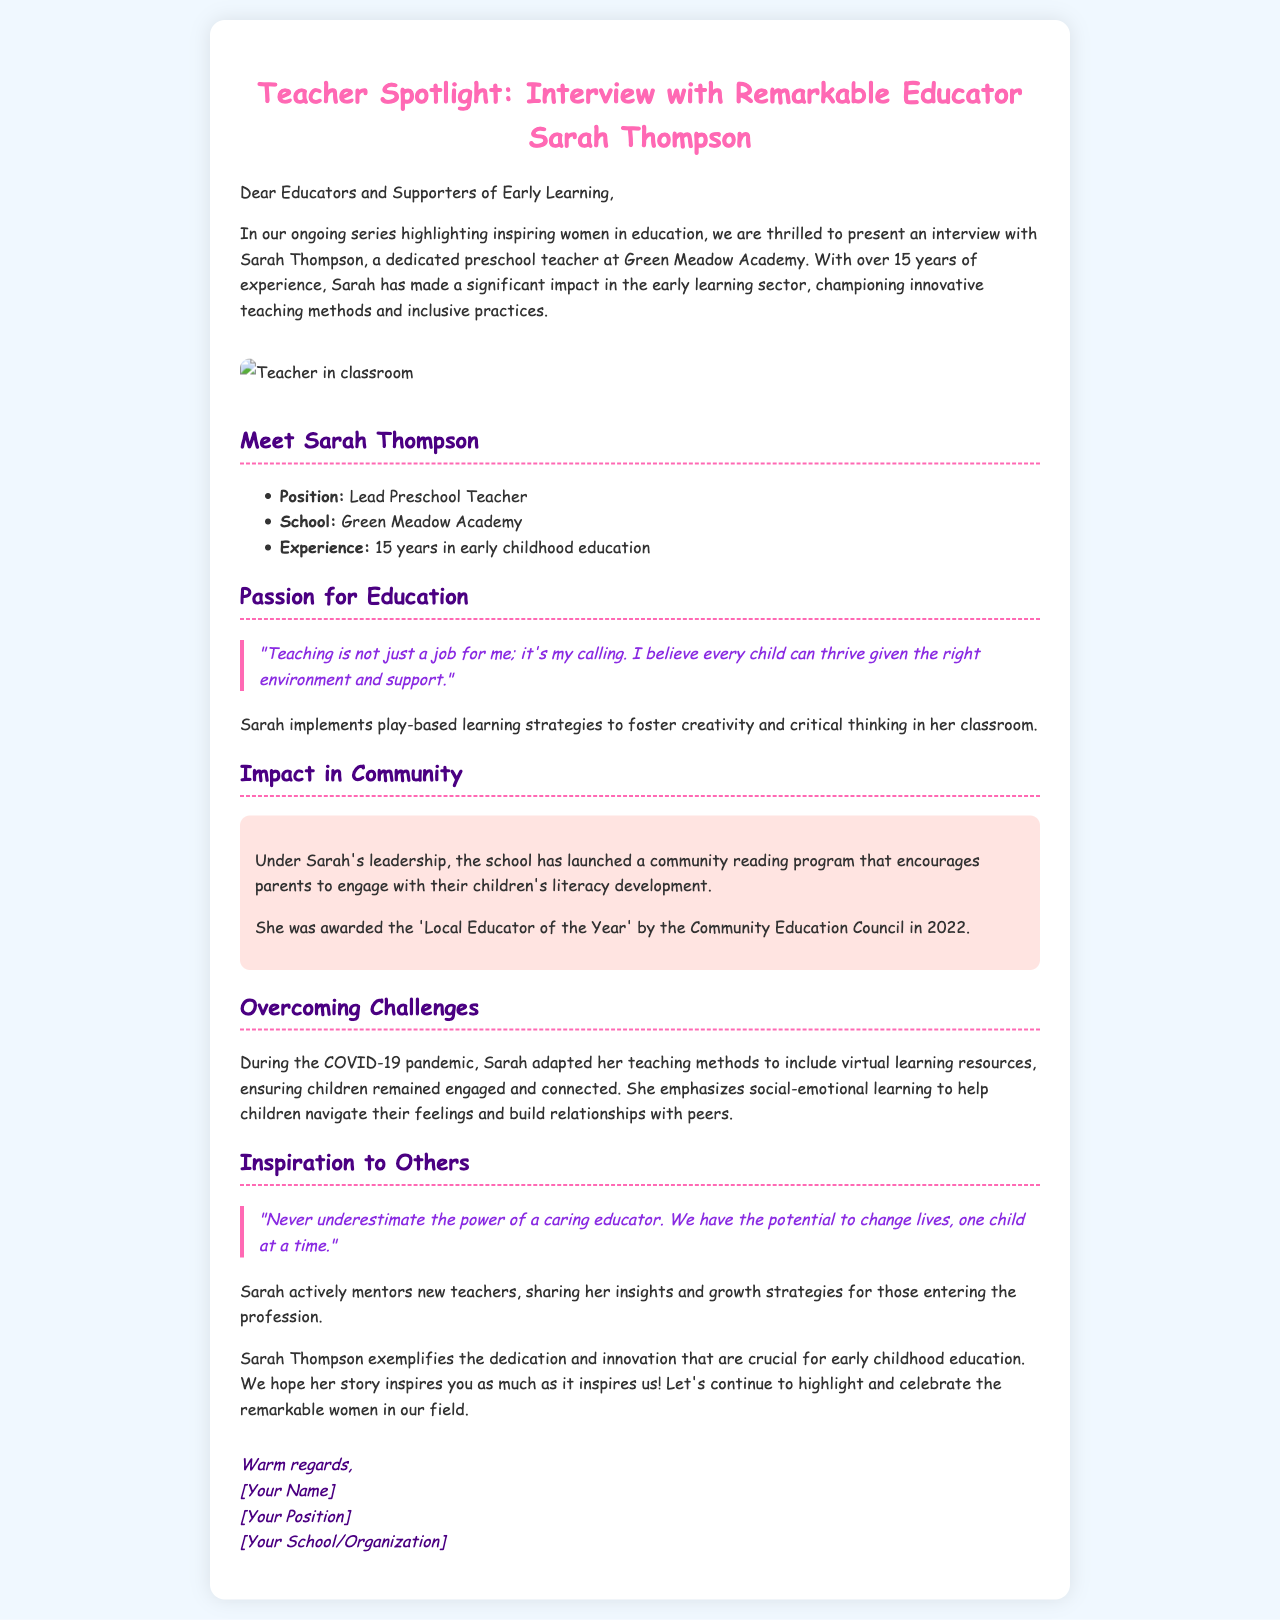What is the name of the featured educator? The document highlights an interview with Sarah Thompson.
Answer: Sarah Thompson What position does Sarah Thompson hold? Sarah is identified as the Lead Preschool Teacher at Green Meadow Academy.
Answer: Lead Preschool Teacher How many years of experience does Sarah have? The document states that Sarah has over 15 years of experience in early childhood education.
Answer: 15 years What innovative strategy does Sarah implement in her classroom? The document mentions that Sarah uses play-based learning strategies.
Answer: Play-based learning What community program did Sarah help launch? Sarah was involved in launching a community reading program at her school.
Answer: Community reading program What award did Sarah receive in 2022? The document indicates that Sarah was awarded the 'Local Educator of the Year' by the Community Education Council.
Answer: Local Educator of the Year How did Sarah adapt her teaching during the COVID-19 pandemic? The document states that she adapted to include virtual learning resources.
Answer: Virtual learning resources What does Sarah emphasize to help children during challenges? Sarah focuses on social-emotional learning to assist children in navigating their feelings.
Answer: Social-emotional learning What quote reflects Sarah's belief about educators? Sarah emphasizes the impact of a caring educator with a quote in the document.
Answer: "Never underestimate the power of a caring educator." 